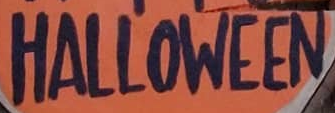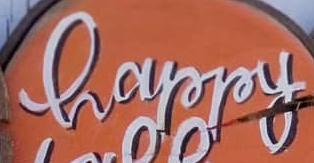Read the text content from these images in order, separated by a semicolon. HALLOWEEN; happy 